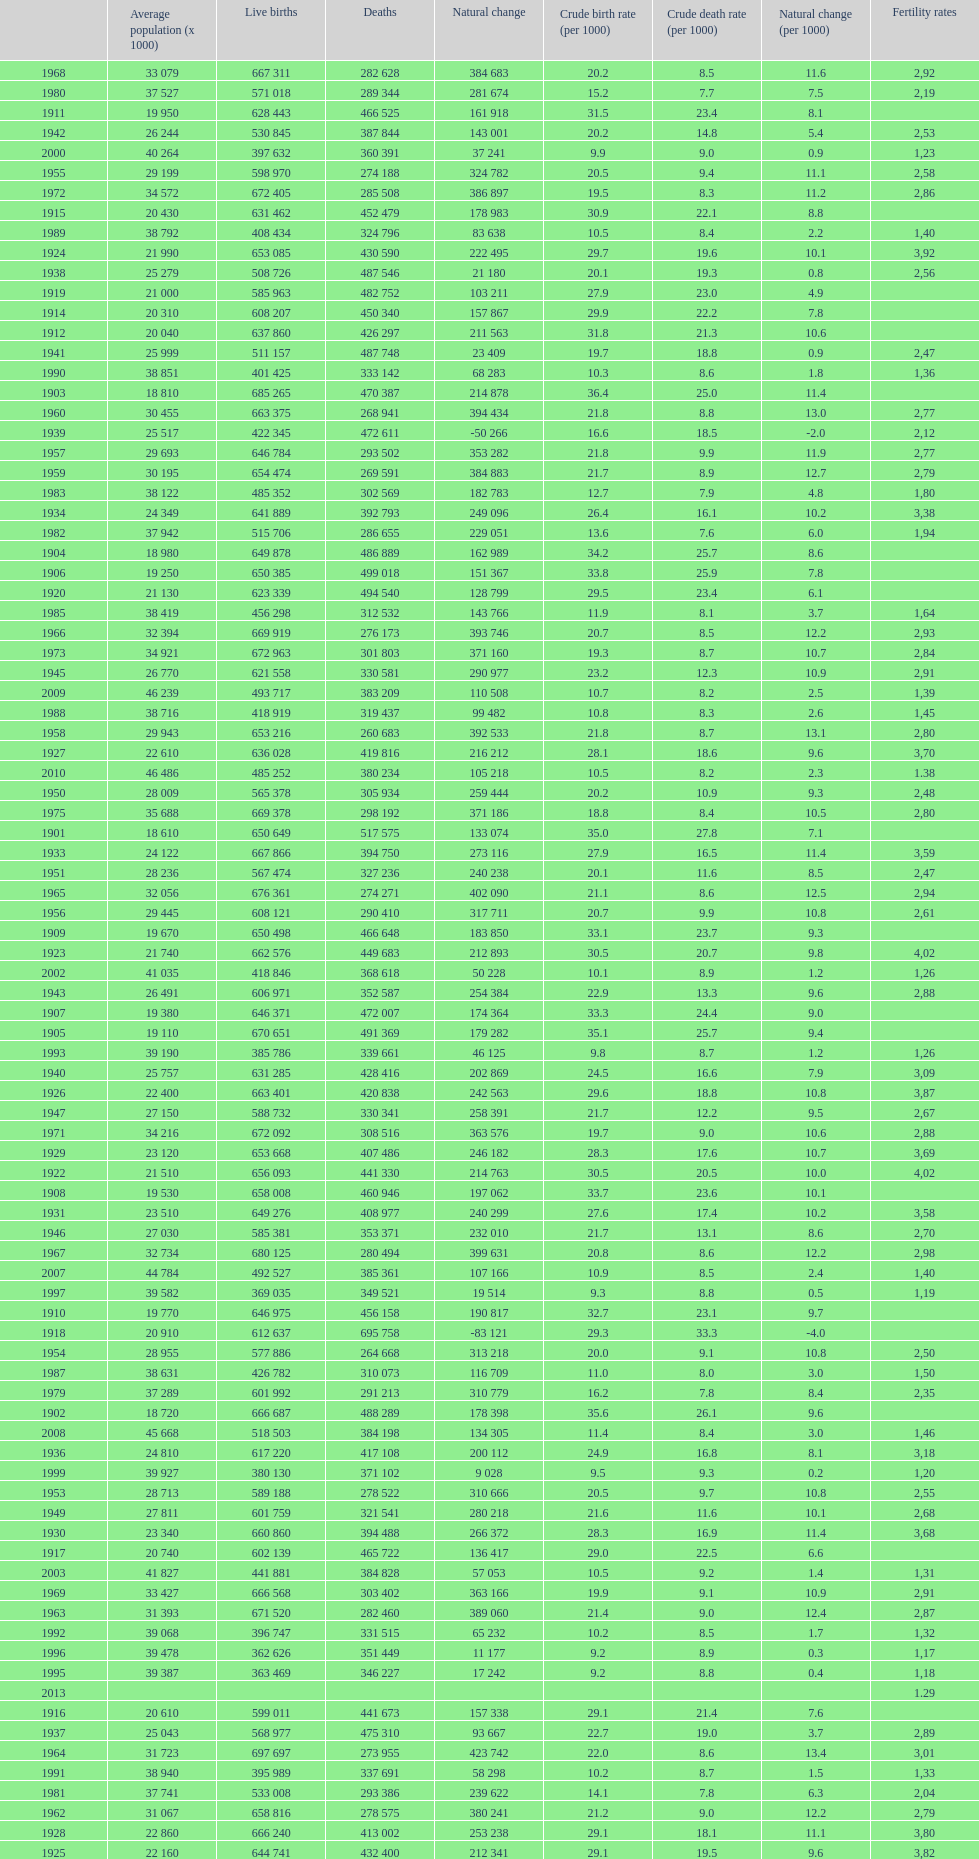Which year has a crude birth rate of 29.1 with a population of 22,860? 1928. 